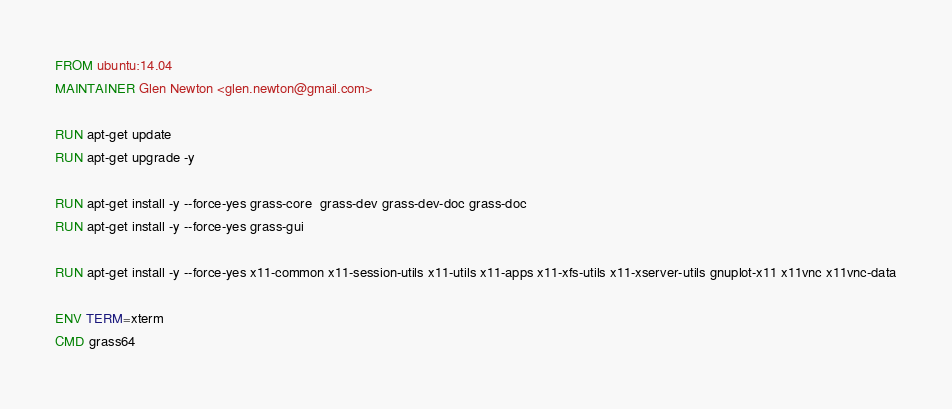Convert code to text. <code><loc_0><loc_0><loc_500><loc_500><_Dockerfile_>
FROM ubuntu:14.04
MAINTAINER Glen Newton <glen.newton@gmail.com>

RUN apt-get update
RUN apt-get upgrade -y

RUN apt-get install -y --force-yes grass-core  grass-dev grass-dev-doc grass-doc
RUN apt-get install -y --force-yes grass-gui

RUN apt-get install -y --force-yes x11-common x11-session-utils x11-utils x11-apps x11-xfs-utils x11-xserver-utils gnuplot-x11 x11vnc x11vnc-data

ENV TERM=xterm
CMD grass64


</code> 